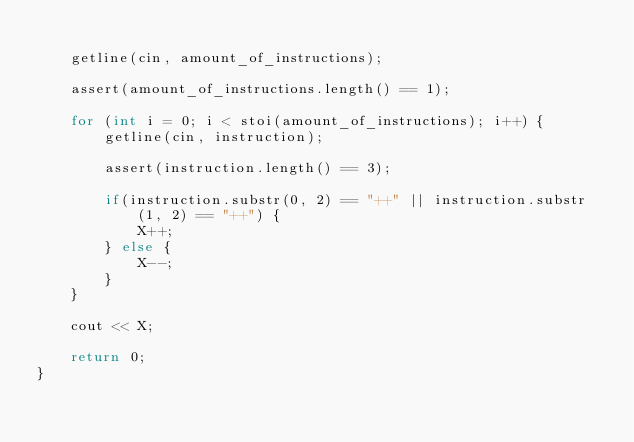<code> <loc_0><loc_0><loc_500><loc_500><_C++_>
    getline(cin, amount_of_instructions);

    assert(amount_of_instructions.length() == 1);

    for (int i = 0; i < stoi(amount_of_instructions); i++) {
        getline(cin, instruction);

        assert(instruction.length() == 3);

        if(instruction.substr(0, 2) == "++" || instruction.substr(1, 2) == "++") {
            X++;
        } else {
            X--;
        }
    }

    cout << X;
    
    return 0;
}</code> 